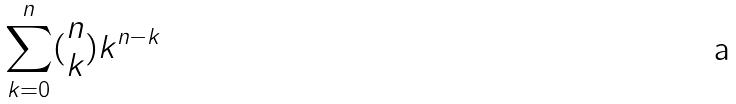Convert formula to latex. <formula><loc_0><loc_0><loc_500><loc_500>\sum _ { k = 0 } ^ { n } ( \begin{matrix} n \\ k \end{matrix} ) k ^ { n - k }</formula> 